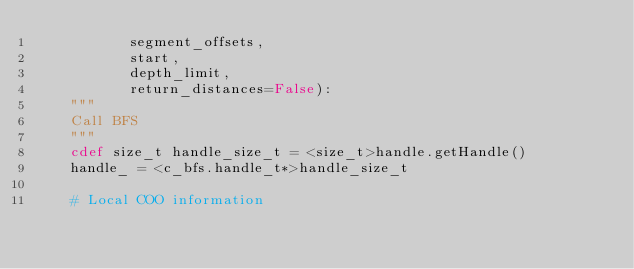Convert code to text. <code><loc_0><loc_0><loc_500><loc_500><_Cython_>           segment_offsets,
           start,
           depth_limit,
           return_distances=False):
    """
    Call BFS
    """
    cdef size_t handle_size_t = <size_t>handle.getHandle()
    handle_ = <c_bfs.handle_t*>handle_size_t

    # Local COO information</code> 